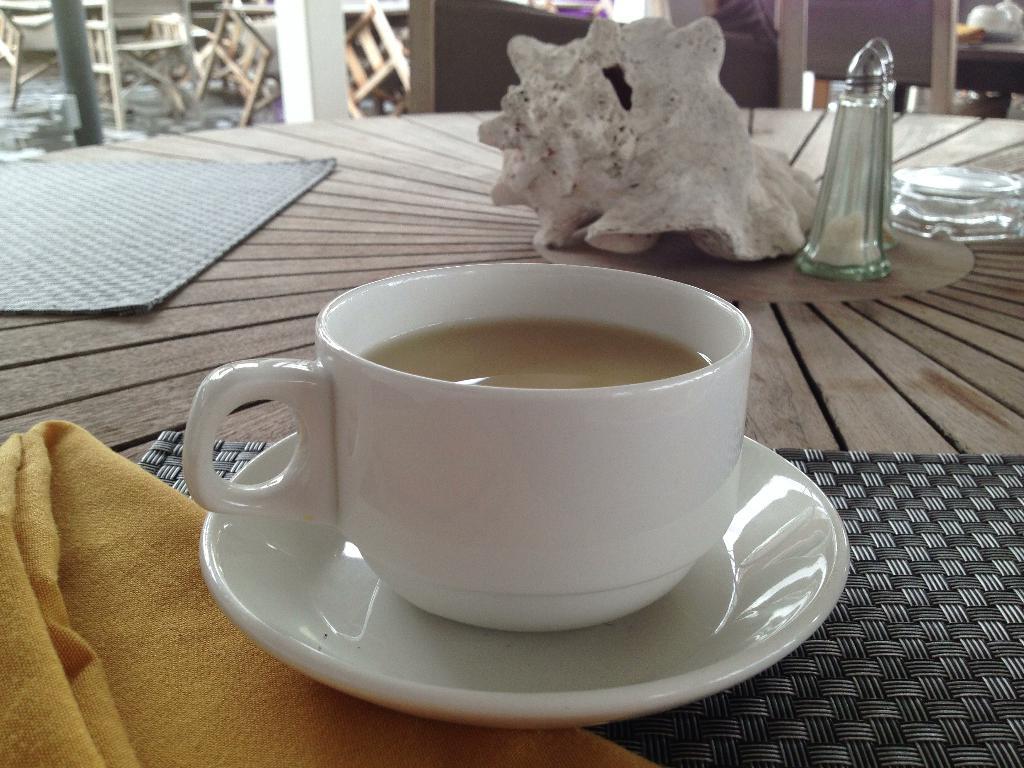Please provide a concise description of this image. In this image i can see a cup with a drink in it and a saucer. In the background i can see a seashell, a table and some chairs. 